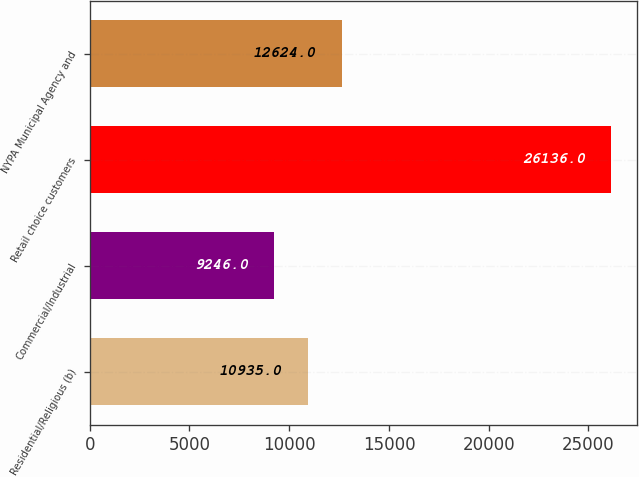<chart> <loc_0><loc_0><loc_500><loc_500><bar_chart><fcel>Residential/Religious (b)<fcel>Commercial/Industrial<fcel>Retail choice customers<fcel>NYPA Municipal Agency and<nl><fcel>10935<fcel>9246<fcel>26136<fcel>12624<nl></chart> 